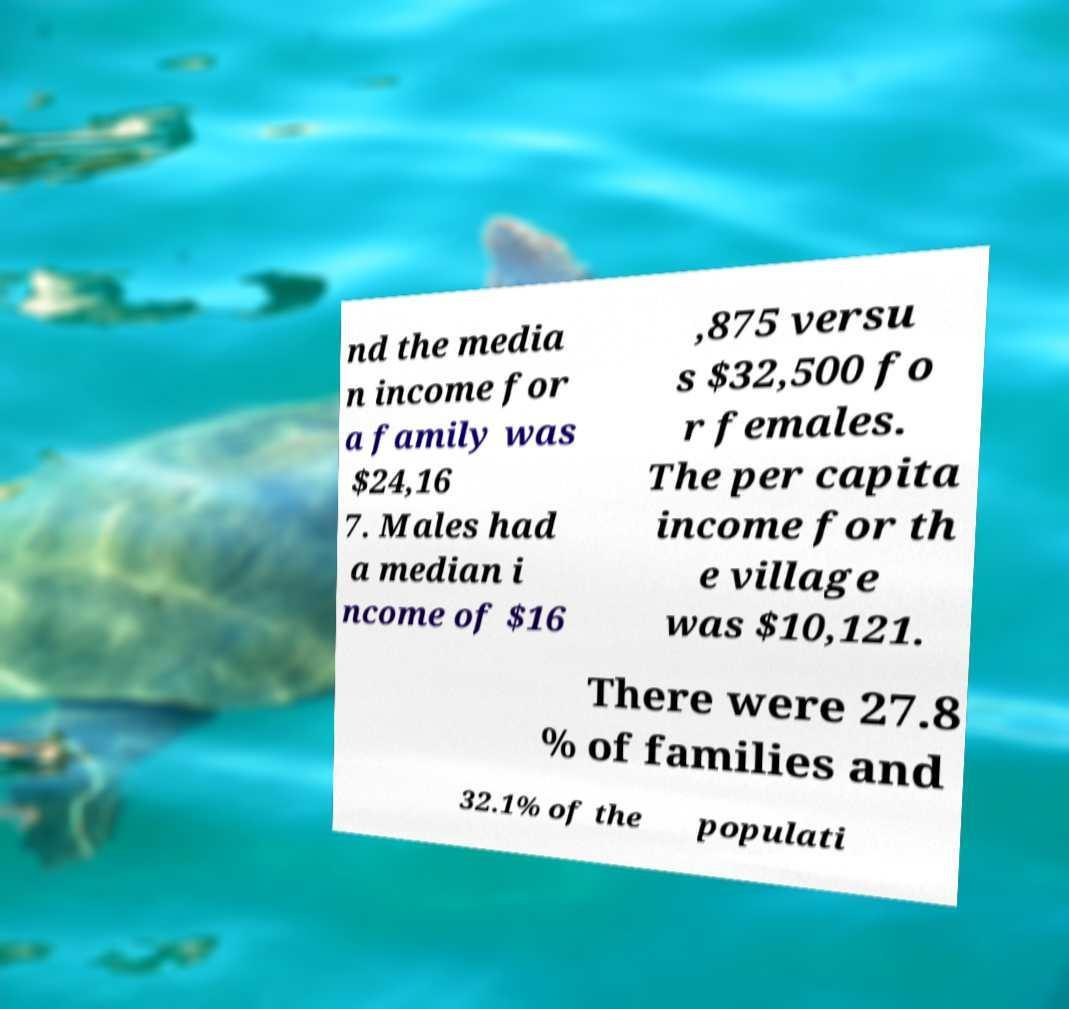What messages or text are displayed in this image? I need them in a readable, typed format. nd the media n income for a family was $24,16 7. Males had a median i ncome of $16 ,875 versu s $32,500 fo r females. The per capita income for th e village was $10,121. There were 27.8 % of families and 32.1% of the populati 